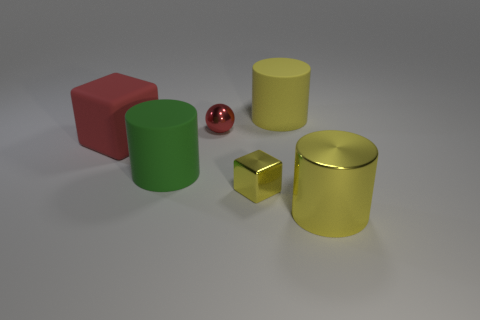Add 4 large yellow matte things. How many objects exist? 10 Subtract all spheres. How many objects are left? 5 Subtract 0 purple cylinders. How many objects are left? 6 Subtract all green metallic things. Subtract all shiny things. How many objects are left? 3 Add 3 yellow shiny things. How many yellow shiny things are left? 5 Add 3 metal balls. How many metal balls exist? 4 